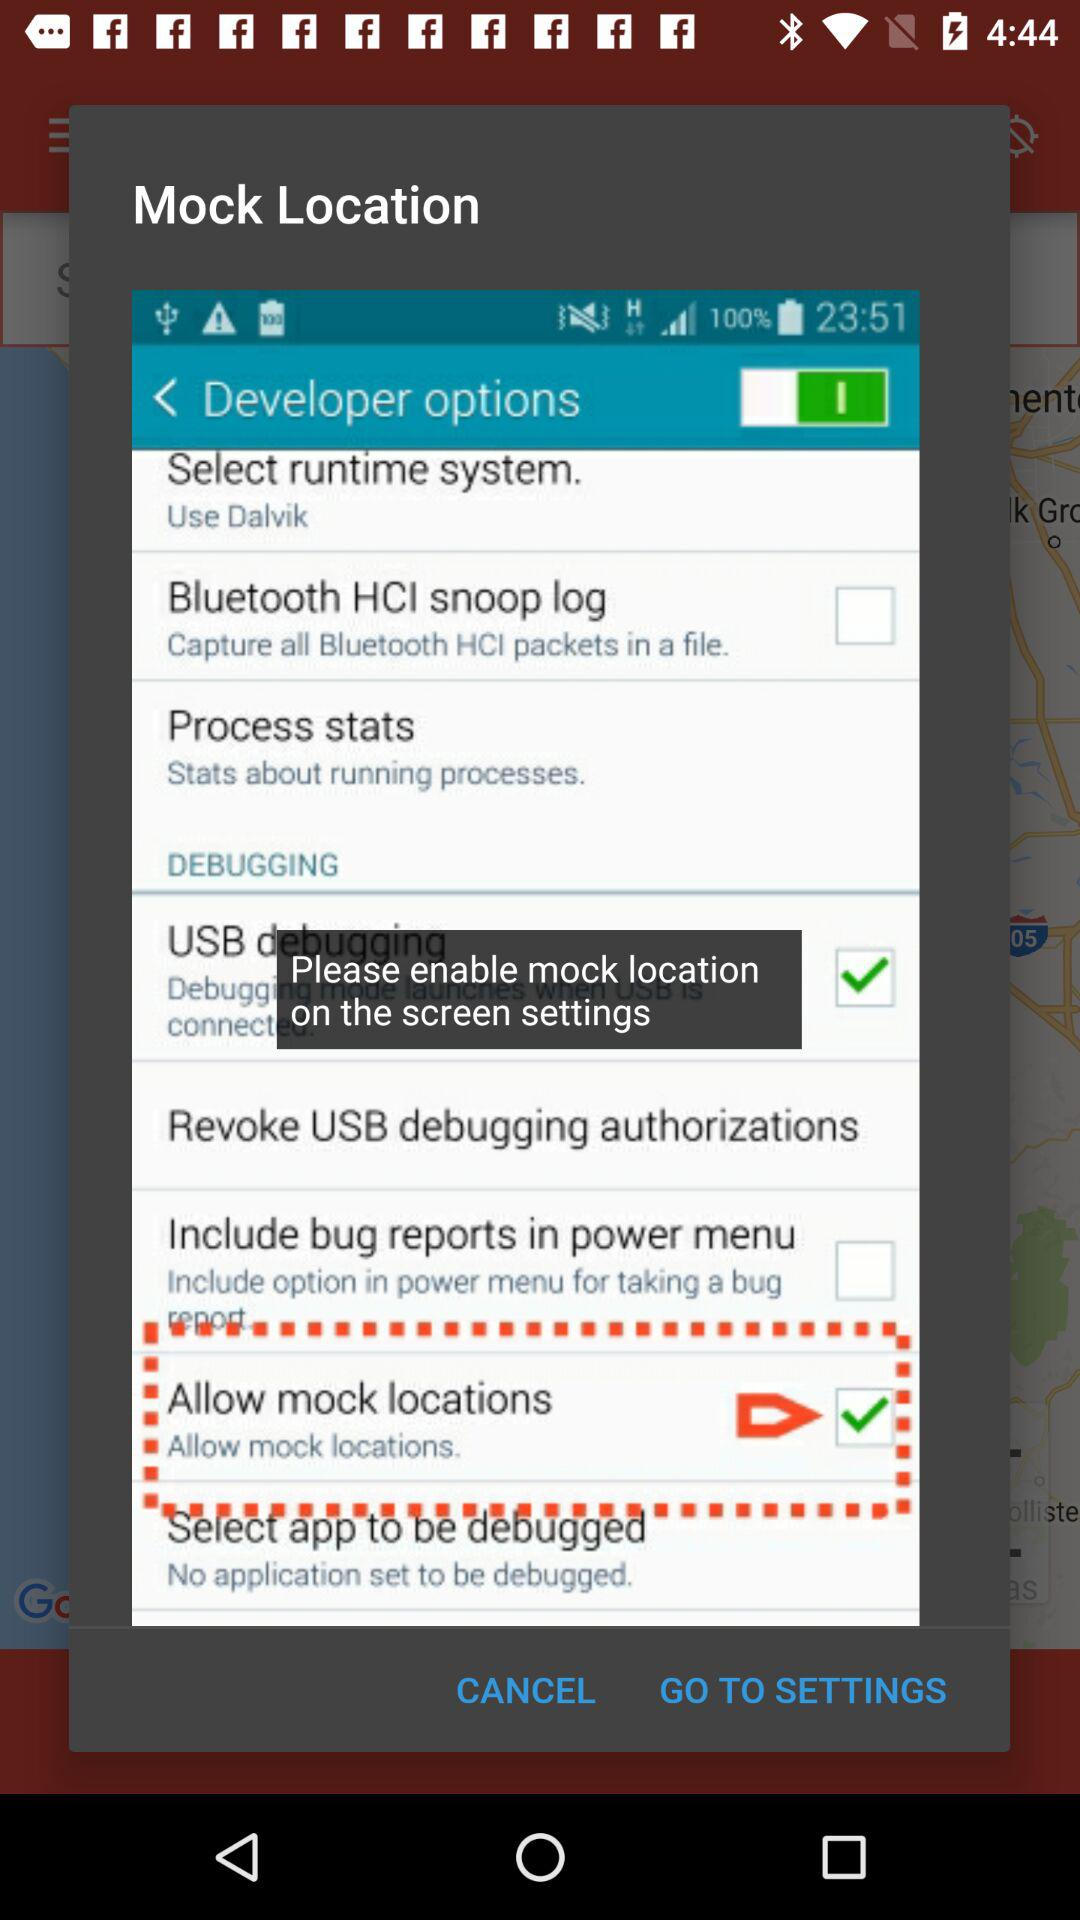What's the current status of "Bluetooth HCI snoop log"? The current status is off. 